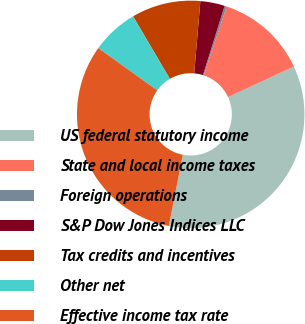<chart> <loc_0><loc_0><loc_500><loc_500><pie_chart><fcel>US federal statutory income<fcel>State and local income taxes<fcel>Foreign operations<fcel>S&P Dow Jones Indices LLC<fcel>Tax credits and incentives<fcel>Other net<fcel>Effective income tax rate<nl><fcel>34.99%<fcel>12.97%<fcel>0.3%<fcel>3.47%<fcel>9.81%<fcel>6.64%<fcel>31.82%<nl></chart> 